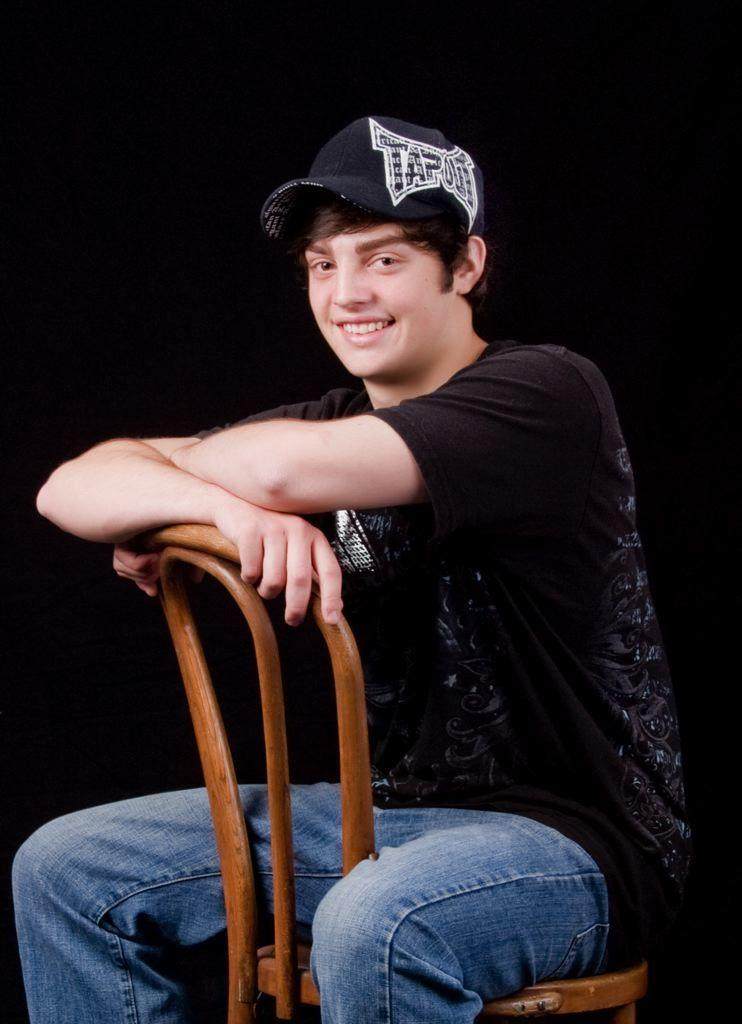Who is the main subject in the image? There is a man in the image. What is the man doing in the image? The man is sitting on a chair. What is the man's facial expression in the image? The man is smiling. What type of clothing is the man wearing on his head? The man is wearing a cap. What type of clothing is the man wearing on his upper body? The man is wearing a T-shirt. What type of clothing is the man wearing on his lower body? The man is wearing jeans. How many sisters does the man have in the image? There is no mention of sisters in the image, so we cannot determine the number of sisters the man has. 